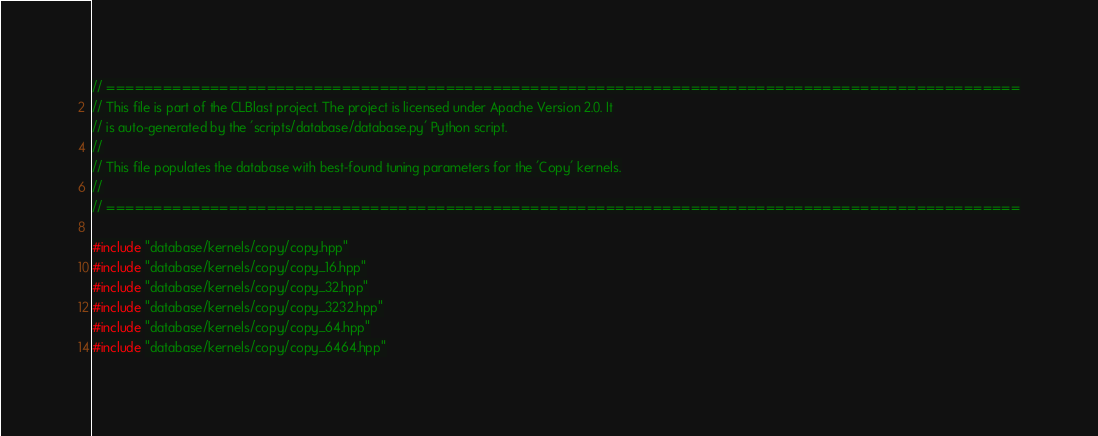Convert code to text. <code><loc_0><loc_0><loc_500><loc_500><_C++_>
// =================================================================================================
// This file is part of the CLBlast project. The project is licensed under Apache Version 2.0. It
// is auto-generated by the 'scripts/database/database.py' Python script.
//
// This file populates the database with best-found tuning parameters for the 'Copy' kernels.
//
// =================================================================================================

#include "database/kernels/copy/copy.hpp"
#include "database/kernels/copy/copy_16.hpp"
#include "database/kernels/copy/copy_32.hpp"
#include "database/kernels/copy/copy_3232.hpp"
#include "database/kernels/copy/copy_64.hpp"
#include "database/kernels/copy/copy_6464.hpp"
</code> 